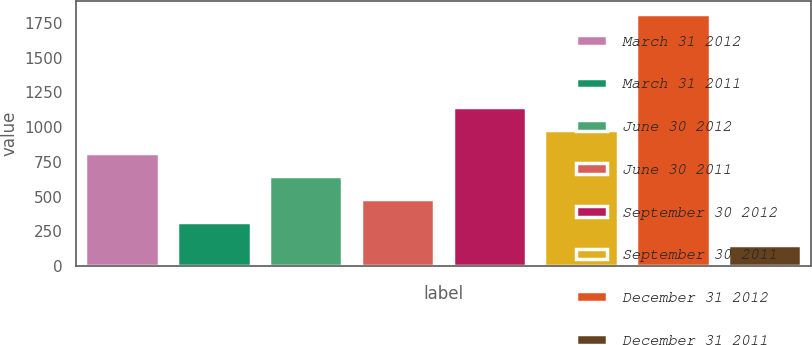Convert chart. <chart><loc_0><loc_0><loc_500><loc_500><bar_chart><fcel>March 31 2012<fcel>March 31 2011<fcel>June 30 2012<fcel>June 30 2011<fcel>September 30 2012<fcel>September 30 2011<fcel>December 31 2012<fcel>December 31 2011<nl><fcel>815.2<fcel>314.8<fcel>648.4<fcel>481.6<fcel>1148.8<fcel>982<fcel>1816<fcel>148<nl></chart> 